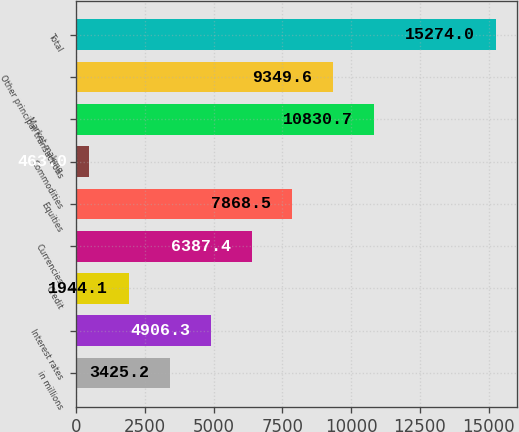Convert chart. <chart><loc_0><loc_0><loc_500><loc_500><bar_chart><fcel>in millions<fcel>Interest rates<fcel>Credit<fcel>Currencies<fcel>Equities<fcel>Commodities<fcel>Market making<fcel>Other principal transactions<fcel>Total<nl><fcel>3425.2<fcel>4906.3<fcel>1944.1<fcel>6387.4<fcel>7868.5<fcel>463<fcel>10830.7<fcel>9349.6<fcel>15274<nl></chart> 